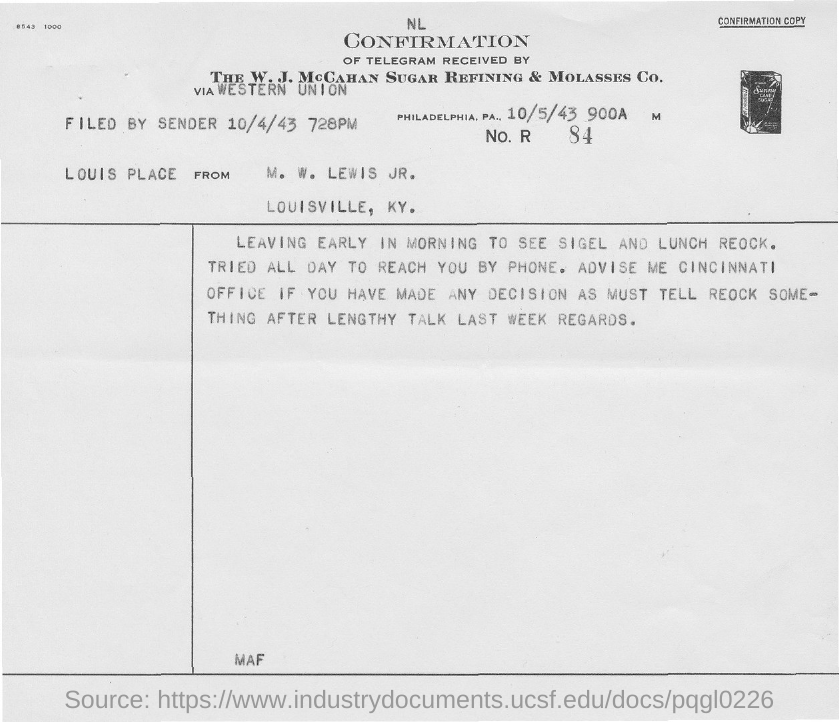Mention a couple of crucial points in this snapshot. The sender filed the letter on October 4, 1943. 